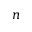Convert formula to latex. <formula><loc_0><loc_0><loc_500><loc_500>n</formula> 